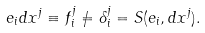Convert formula to latex. <formula><loc_0><loc_0><loc_500><loc_500>e _ { i } d x ^ { j } \equiv f _ { i } ^ { j } \neq \delta _ { i } ^ { j } = S ( e _ { i } , d x ^ { j } ) .</formula> 